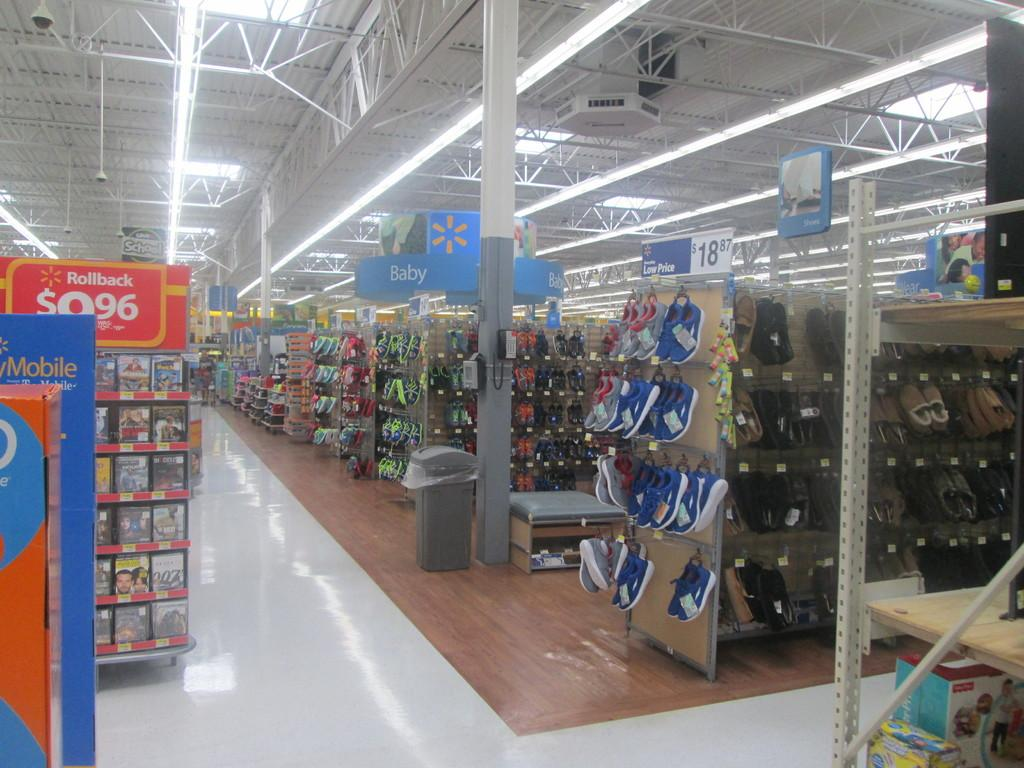Provide a one-sentence caption for the provided image. Walmart store with empty aisles and a section for Rollback DVDs. 